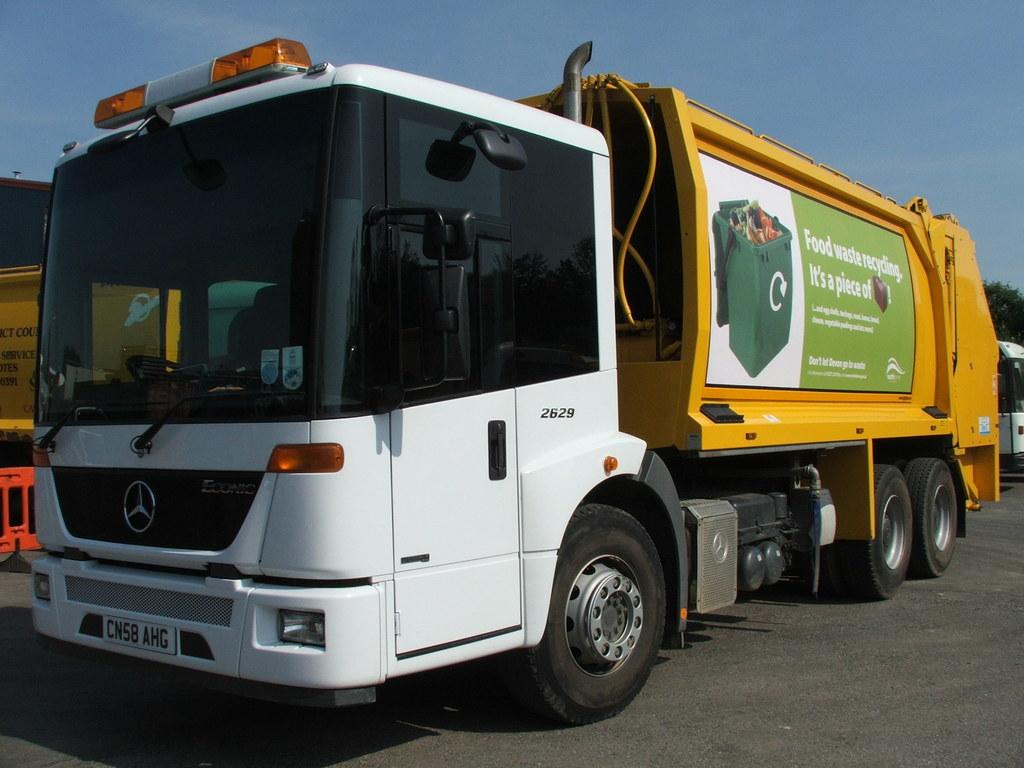Who manufactured this truck?
Offer a very short reply. Answering does not require reading text in the image. What is written on the green background?
Keep it short and to the point. Food waste recycling. 